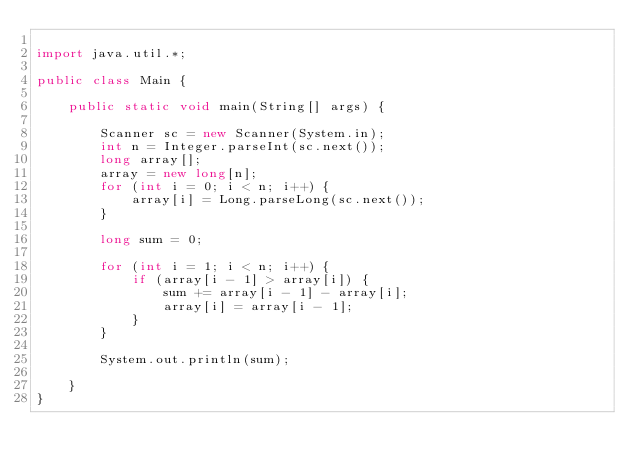Convert code to text. <code><loc_0><loc_0><loc_500><loc_500><_Java_>
import java.util.*;

public class Main {

	public static void main(String[] args) {

		Scanner sc = new Scanner(System.in);
		int n = Integer.parseInt(sc.next());
		long array[];
		array = new long[n];
		for (int i = 0; i < n; i++) {
			array[i] = Long.parseLong(sc.next());
		}

		long sum = 0;

		for (int i = 1; i < n; i++) {
			if (array[i - 1] > array[i]) {
				sum += array[i - 1] - array[i];
				array[i] = array[i - 1];
			}
		}

		System.out.println(sum);

	}
}</code> 